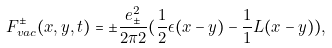<formula> <loc_0><loc_0><loc_500><loc_500>F _ { v a c } ^ { \pm } ( x , y , t ) = \pm \frac { e _ { \pm } ^ { 2 } } { 2 \pi { 2 } } ( \frac { 1 } { 2 } \epsilon ( x - y ) - \frac { 1 } { 1 } L ( x - y ) ) ,</formula> 